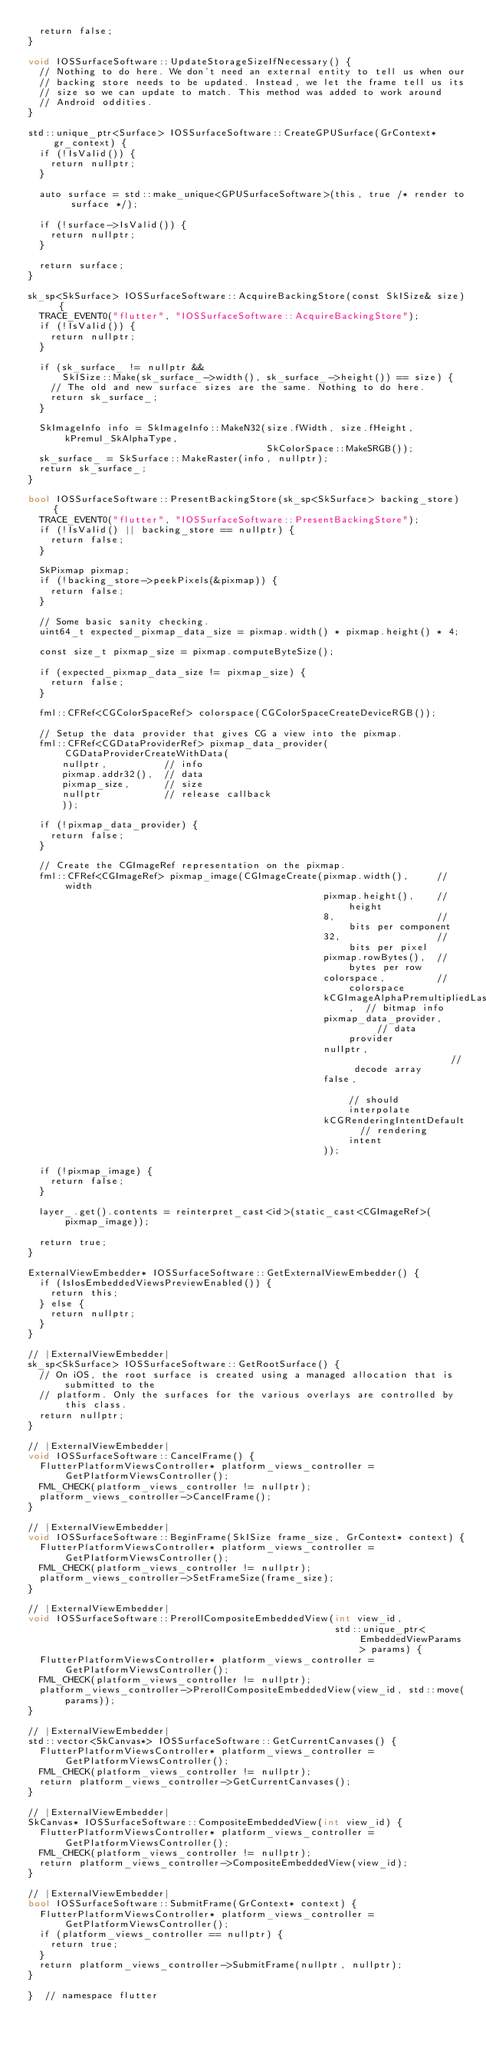<code> <loc_0><loc_0><loc_500><loc_500><_ObjectiveC_>  return false;
}

void IOSSurfaceSoftware::UpdateStorageSizeIfNecessary() {
  // Nothing to do here. We don't need an external entity to tell us when our
  // backing store needs to be updated. Instead, we let the frame tell us its
  // size so we can update to match. This method was added to work around
  // Android oddities.
}

std::unique_ptr<Surface> IOSSurfaceSoftware::CreateGPUSurface(GrContext* gr_context) {
  if (!IsValid()) {
    return nullptr;
  }

  auto surface = std::make_unique<GPUSurfaceSoftware>(this, true /* render to surface */);

  if (!surface->IsValid()) {
    return nullptr;
  }

  return surface;
}

sk_sp<SkSurface> IOSSurfaceSoftware::AcquireBackingStore(const SkISize& size) {
  TRACE_EVENT0("flutter", "IOSSurfaceSoftware::AcquireBackingStore");
  if (!IsValid()) {
    return nullptr;
  }

  if (sk_surface_ != nullptr &&
      SkISize::Make(sk_surface_->width(), sk_surface_->height()) == size) {
    // The old and new surface sizes are the same. Nothing to do here.
    return sk_surface_;
  }

  SkImageInfo info = SkImageInfo::MakeN32(size.fWidth, size.fHeight, kPremul_SkAlphaType,
                                          SkColorSpace::MakeSRGB());
  sk_surface_ = SkSurface::MakeRaster(info, nullptr);
  return sk_surface_;
}

bool IOSSurfaceSoftware::PresentBackingStore(sk_sp<SkSurface> backing_store) {
  TRACE_EVENT0("flutter", "IOSSurfaceSoftware::PresentBackingStore");
  if (!IsValid() || backing_store == nullptr) {
    return false;
  }

  SkPixmap pixmap;
  if (!backing_store->peekPixels(&pixmap)) {
    return false;
  }

  // Some basic sanity checking.
  uint64_t expected_pixmap_data_size = pixmap.width() * pixmap.height() * 4;

  const size_t pixmap_size = pixmap.computeByteSize();

  if (expected_pixmap_data_size != pixmap_size) {
    return false;
  }

  fml::CFRef<CGColorSpaceRef> colorspace(CGColorSpaceCreateDeviceRGB());

  // Setup the data provider that gives CG a view into the pixmap.
  fml::CFRef<CGDataProviderRef> pixmap_data_provider(CGDataProviderCreateWithData(
      nullptr,          // info
      pixmap.addr32(),  // data
      pixmap_size,      // size
      nullptr           // release callback
      ));

  if (!pixmap_data_provider) {
    return false;
  }

  // Create the CGImageRef representation on the pixmap.
  fml::CFRef<CGImageRef> pixmap_image(CGImageCreate(pixmap.width(),     // width
                                                    pixmap.height(),    // height
                                                    8,                  // bits per component
                                                    32,                 // bits per pixel
                                                    pixmap.rowBytes(),  // bytes per row
                                                    colorspace,         // colorspace
                                                    kCGImageAlphaPremultipliedLast,  // bitmap info
                                                    pixmap_data_provider,      // data provider
                                                    nullptr,                   // decode array
                                                    false,                     // should interpolate
                                                    kCGRenderingIntentDefault  // rendering intent
                                                    ));

  if (!pixmap_image) {
    return false;
  }

  layer_.get().contents = reinterpret_cast<id>(static_cast<CGImageRef>(pixmap_image));

  return true;
}

ExternalViewEmbedder* IOSSurfaceSoftware::GetExternalViewEmbedder() {
  if (IsIosEmbeddedViewsPreviewEnabled()) {
    return this;
  } else {
    return nullptr;
  }
}

// |ExternalViewEmbedder|
sk_sp<SkSurface> IOSSurfaceSoftware::GetRootSurface() {
  // On iOS, the root surface is created using a managed allocation that is submitted to the
  // platform. Only the surfaces for the various overlays are controlled by this class.
  return nullptr;
}

// |ExternalViewEmbedder|
void IOSSurfaceSoftware::CancelFrame() {
  FlutterPlatformViewsController* platform_views_controller = GetPlatformViewsController();
  FML_CHECK(platform_views_controller != nullptr);
  platform_views_controller->CancelFrame();
}

// |ExternalViewEmbedder|
void IOSSurfaceSoftware::BeginFrame(SkISize frame_size, GrContext* context) {
  FlutterPlatformViewsController* platform_views_controller = GetPlatformViewsController();
  FML_CHECK(platform_views_controller != nullptr);
  platform_views_controller->SetFrameSize(frame_size);
}

// |ExternalViewEmbedder|
void IOSSurfaceSoftware::PrerollCompositeEmbeddedView(int view_id,
                                                      std::unique_ptr<EmbeddedViewParams> params) {
  FlutterPlatformViewsController* platform_views_controller = GetPlatformViewsController();
  FML_CHECK(platform_views_controller != nullptr);
  platform_views_controller->PrerollCompositeEmbeddedView(view_id, std::move(params));
}

// |ExternalViewEmbedder|
std::vector<SkCanvas*> IOSSurfaceSoftware::GetCurrentCanvases() {
  FlutterPlatformViewsController* platform_views_controller = GetPlatformViewsController();
  FML_CHECK(platform_views_controller != nullptr);
  return platform_views_controller->GetCurrentCanvases();
}

// |ExternalViewEmbedder|
SkCanvas* IOSSurfaceSoftware::CompositeEmbeddedView(int view_id) {
  FlutterPlatformViewsController* platform_views_controller = GetPlatformViewsController();
  FML_CHECK(platform_views_controller != nullptr);
  return platform_views_controller->CompositeEmbeddedView(view_id);
}

// |ExternalViewEmbedder|
bool IOSSurfaceSoftware::SubmitFrame(GrContext* context) {
  FlutterPlatformViewsController* platform_views_controller = GetPlatformViewsController();
  if (platform_views_controller == nullptr) {
    return true;
  }
  return platform_views_controller->SubmitFrame(nullptr, nullptr);
}

}  // namespace flutter
</code> 